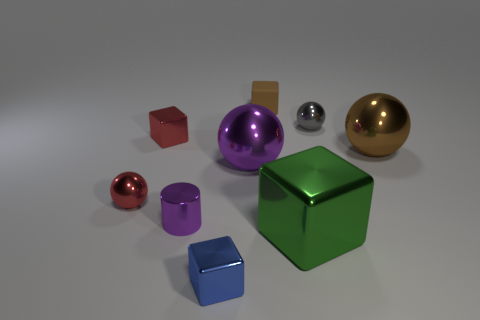Subtract all gray balls. How many balls are left? 3 Subtract all blue blocks. How many blocks are left? 3 Subtract 2 balls. How many balls are left? 2 Add 1 small blue cubes. How many objects exist? 10 Subtract all green balls. Subtract all purple cylinders. How many balls are left? 4 Subtract all cylinders. How many objects are left? 8 Subtract all purple things. Subtract all gray metal spheres. How many objects are left? 6 Add 6 large things. How many large things are left? 9 Add 7 big cyan metal objects. How many big cyan metal objects exist? 7 Subtract 0 brown cylinders. How many objects are left? 9 